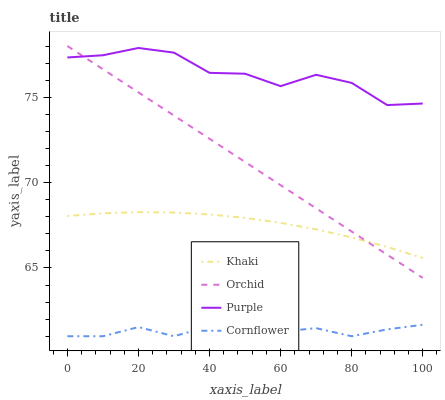Does Cornflower have the minimum area under the curve?
Answer yes or no. Yes. Does Purple have the maximum area under the curve?
Answer yes or no. Yes. Does Khaki have the minimum area under the curve?
Answer yes or no. No. Does Khaki have the maximum area under the curve?
Answer yes or no. No. Is Orchid the smoothest?
Answer yes or no. Yes. Is Purple the roughest?
Answer yes or no. Yes. Is Cornflower the smoothest?
Answer yes or no. No. Is Cornflower the roughest?
Answer yes or no. No. Does Khaki have the lowest value?
Answer yes or no. No. Does Orchid have the highest value?
Answer yes or no. Yes. Does Khaki have the highest value?
Answer yes or no. No. Is Cornflower less than Khaki?
Answer yes or no. Yes. Is Orchid greater than Cornflower?
Answer yes or no. Yes. Does Purple intersect Orchid?
Answer yes or no. Yes. Is Purple less than Orchid?
Answer yes or no. No. Is Purple greater than Orchid?
Answer yes or no. No. Does Cornflower intersect Khaki?
Answer yes or no. No. 